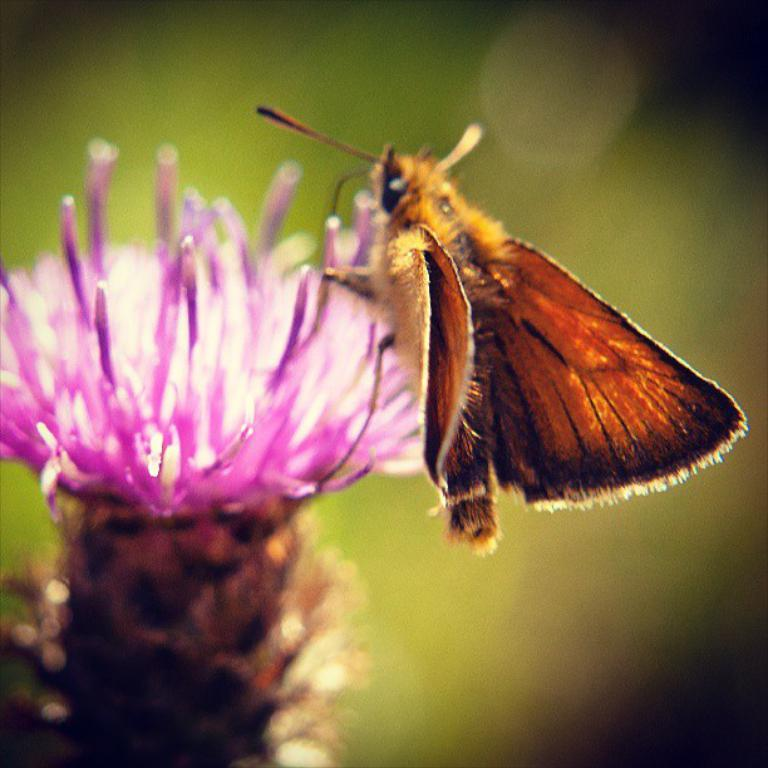What is the main subject of the image? There is a flower in the image. Is there anything else present on the flower? Yes, there is an insect on the flower. How would you describe the overall quality of the image? The image is slightly blurry in the background. What type of coat is the insect wearing in the image? There is no coat present in the image, as insects do not wear clothing. 